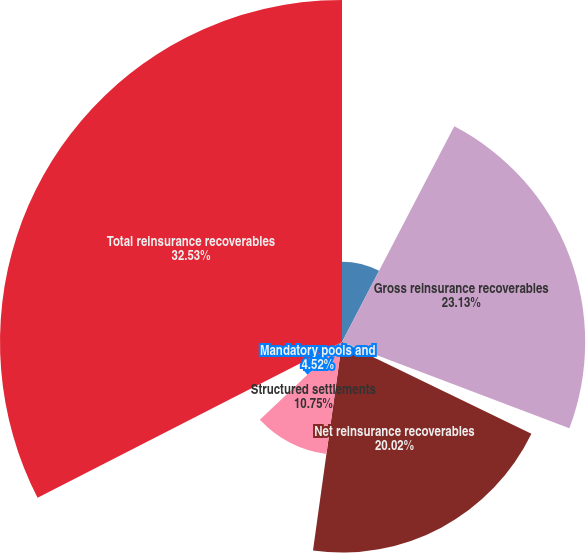<chart> <loc_0><loc_0><loc_500><loc_500><pie_chart><fcel>(at December 31 in millions)<fcel>Gross reinsurance recoverables<fcel>Allowance for uncollectible<fcel>Net reinsurance recoverables<fcel>Structured settlements<fcel>Mandatory pools and<fcel>Total reinsurance recoverables<nl><fcel>7.64%<fcel>23.13%<fcel>1.41%<fcel>20.02%<fcel>10.75%<fcel>4.52%<fcel>32.53%<nl></chart> 